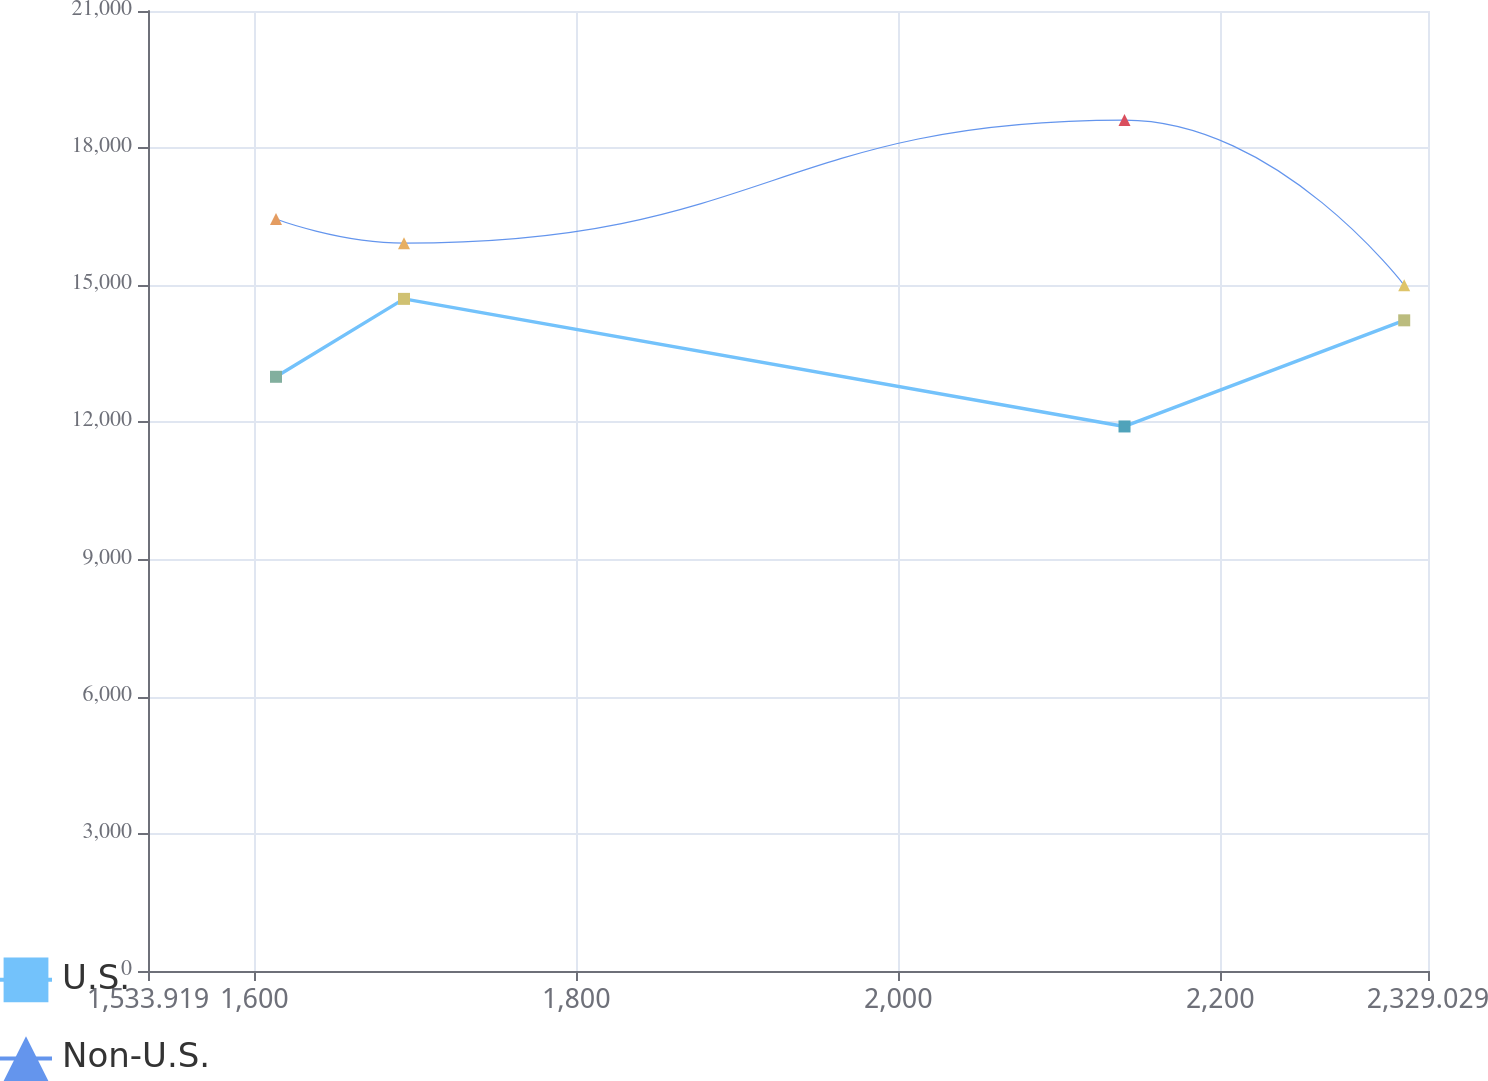<chart> <loc_0><loc_0><loc_500><loc_500><line_chart><ecel><fcel>U.S.<fcel>Non-U.S.<nl><fcel>1613.43<fcel>12998.2<fcel>16448.7<nl><fcel>1692.94<fcel>14702.9<fcel>15922.1<nl><fcel>2140.51<fcel>11911.9<fcel>18613.3<nl><fcel>2314.25<fcel>14233.5<fcel>15000.3<nl><fcel>2408.54<fcel>16606.4<fcel>17117.7<nl></chart> 